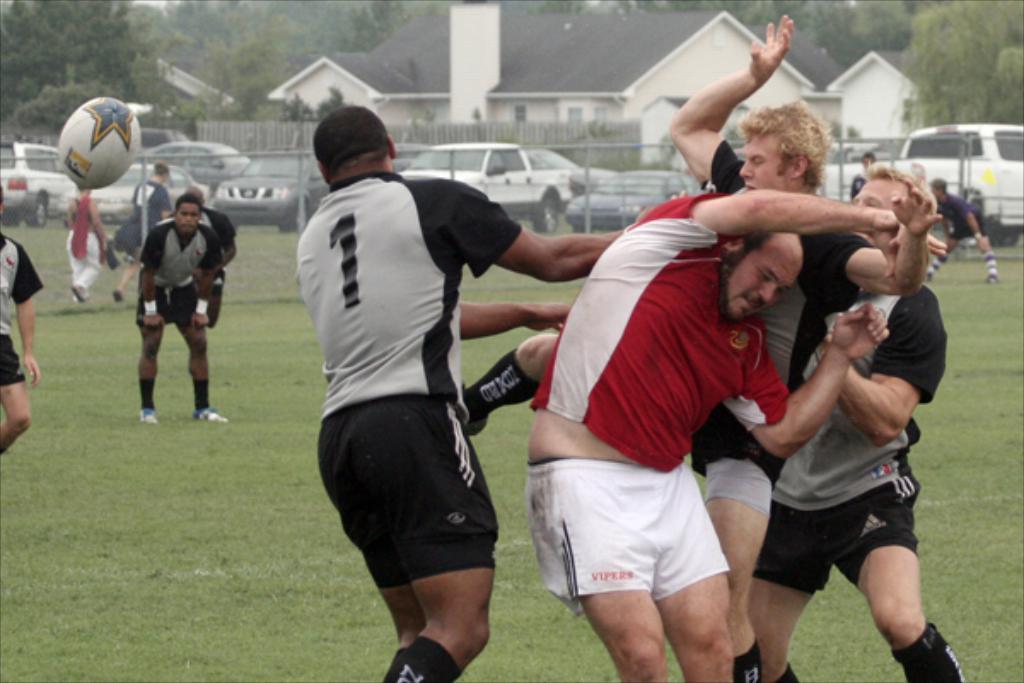Could you give a brief overview of what you see in this image? In this image, there are a few people. We can see the ground covered with grass. There are a few vehicles, houses, trees. We can also see the fence and a ball. 